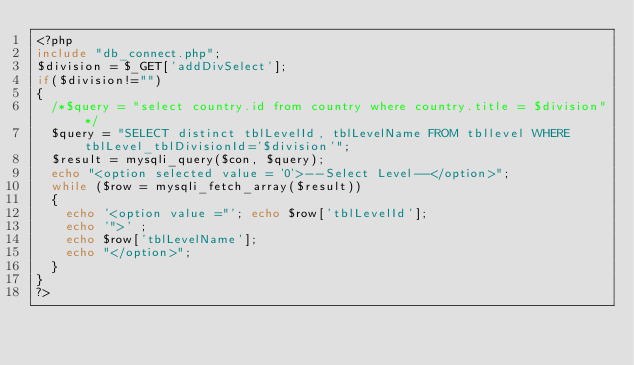<code> <loc_0><loc_0><loc_500><loc_500><_PHP_><?php
include "db_connect.php";
$division = $_GET['addDivSelect'];
if($division!="")
{
	/*$query = "select country.id from country where country.title = $division"*/
	$query = "SELECT distinct tblLevelId, tblLevelName FROM tbllevel WHERE tblLevel_tblDivisionId='$division'";
	$result = mysqli_query($con, $query);
	echo "<option selected value = '0'>--Select Level--</option>";
	while ($row = mysqli_fetch_array($result))
	{
		echo '<option value ="'; echo $row['tblLevelId'];
		echo '">' ; 
		echo $row['tblLevelName']; 
		echo "</option>";
	}
}
?>
</code> 